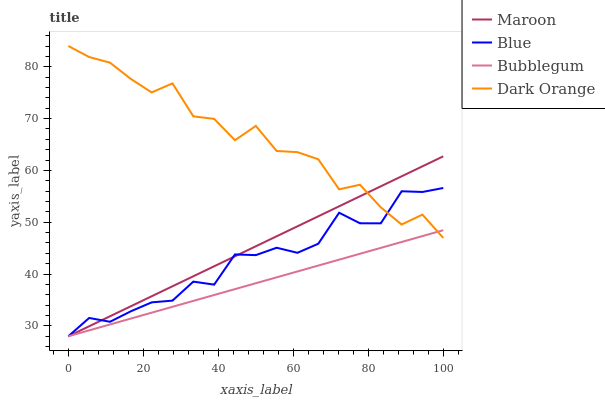Does Bubblegum have the minimum area under the curve?
Answer yes or no. Yes. Does Dark Orange have the maximum area under the curve?
Answer yes or no. Yes. Does Dark Orange have the minimum area under the curve?
Answer yes or no. No. Does Bubblegum have the maximum area under the curve?
Answer yes or no. No. Is Maroon the smoothest?
Answer yes or no. Yes. Is Dark Orange the roughest?
Answer yes or no. Yes. Is Bubblegum the smoothest?
Answer yes or no. No. Is Bubblegum the roughest?
Answer yes or no. No. Does Blue have the lowest value?
Answer yes or no. Yes. Does Dark Orange have the lowest value?
Answer yes or no. No. Does Dark Orange have the highest value?
Answer yes or no. Yes. Does Bubblegum have the highest value?
Answer yes or no. No. Does Maroon intersect Dark Orange?
Answer yes or no. Yes. Is Maroon less than Dark Orange?
Answer yes or no. No. Is Maroon greater than Dark Orange?
Answer yes or no. No. 